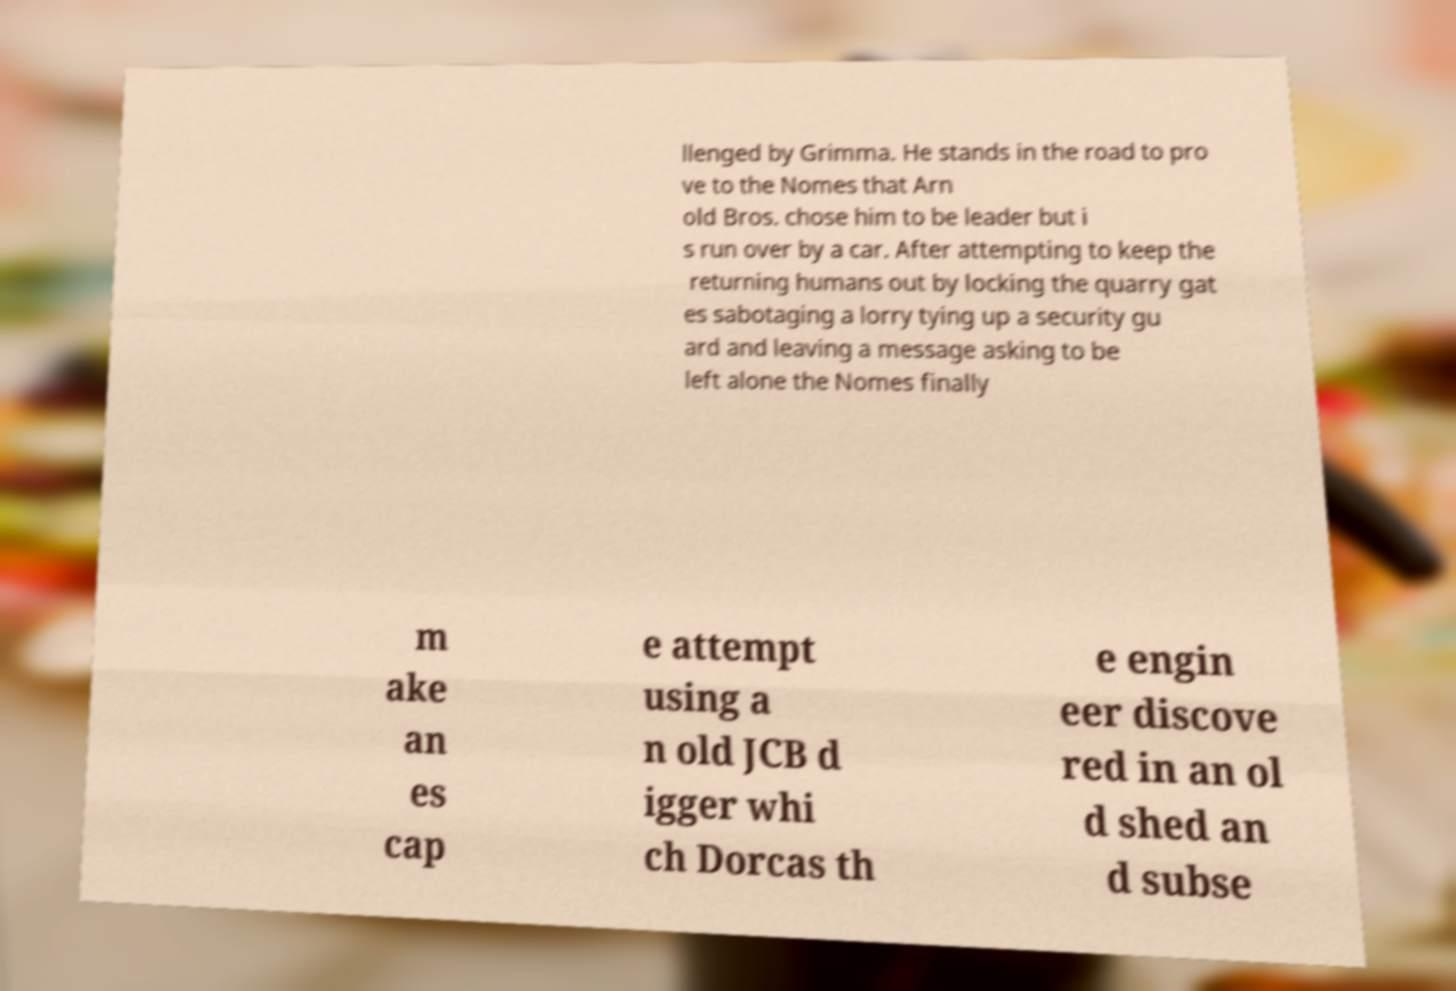What messages or text are displayed in this image? I need them in a readable, typed format. llenged by Grimma. He stands in the road to pro ve to the Nomes that Arn old Bros. chose him to be leader but i s run over by a car. After attempting to keep the returning humans out by locking the quarry gat es sabotaging a lorry tying up a security gu ard and leaving a message asking to be left alone the Nomes finally m ake an es cap e attempt using a n old JCB d igger whi ch Dorcas th e engin eer discove red in an ol d shed an d subse 